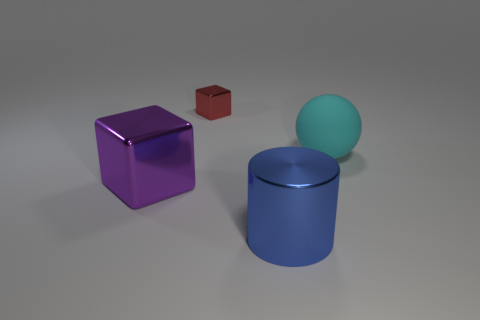Add 3 blue shiny cylinders. How many objects exist? 7 Subtract all spheres. How many objects are left? 3 Subtract all purple metallic cubes. Subtract all cubes. How many objects are left? 1 Add 4 large blue cylinders. How many large blue cylinders are left? 5 Add 1 blue metal cylinders. How many blue metal cylinders exist? 2 Subtract 0 brown cylinders. How many objects are left? 4 